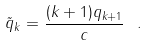Convert formula to latex. <formula><loc_0><loc_0><loc_500><loc_500>\tilde { q } _ { k } = \frac { ( k + 1 ) q _ { k + 1 } } { c } \ .</formula> 